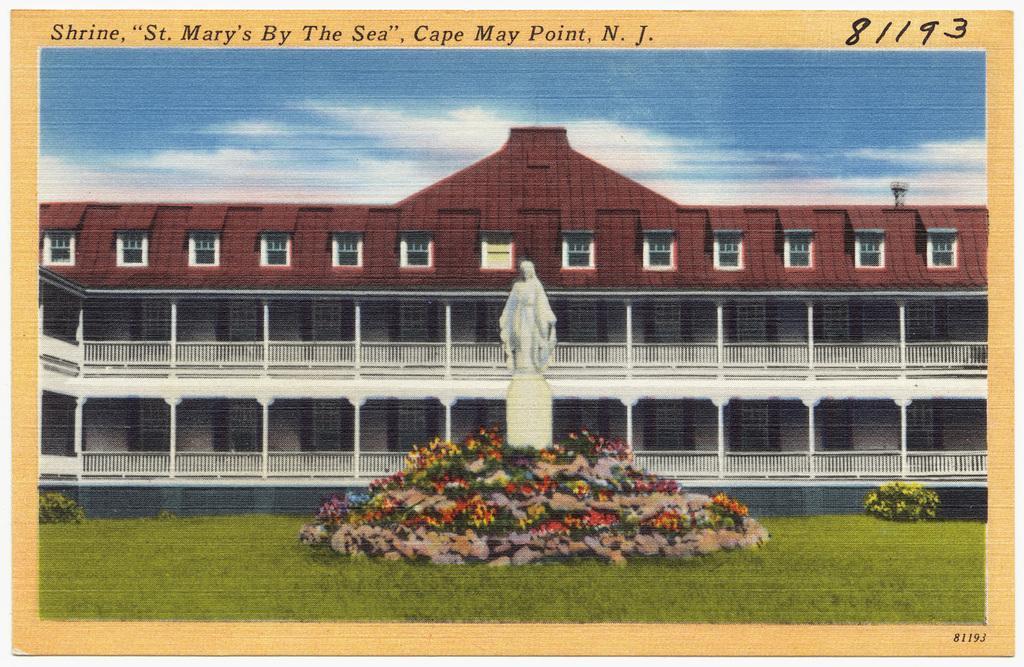Please provide a concise description of this image. This looks like a poster. I can see the letters in the poster. This is the building with windows and pillars. This is the sculpture, which is placed on the pillar. These are the small plants with colorful flowers. I can see the bushes. This is the grass. 